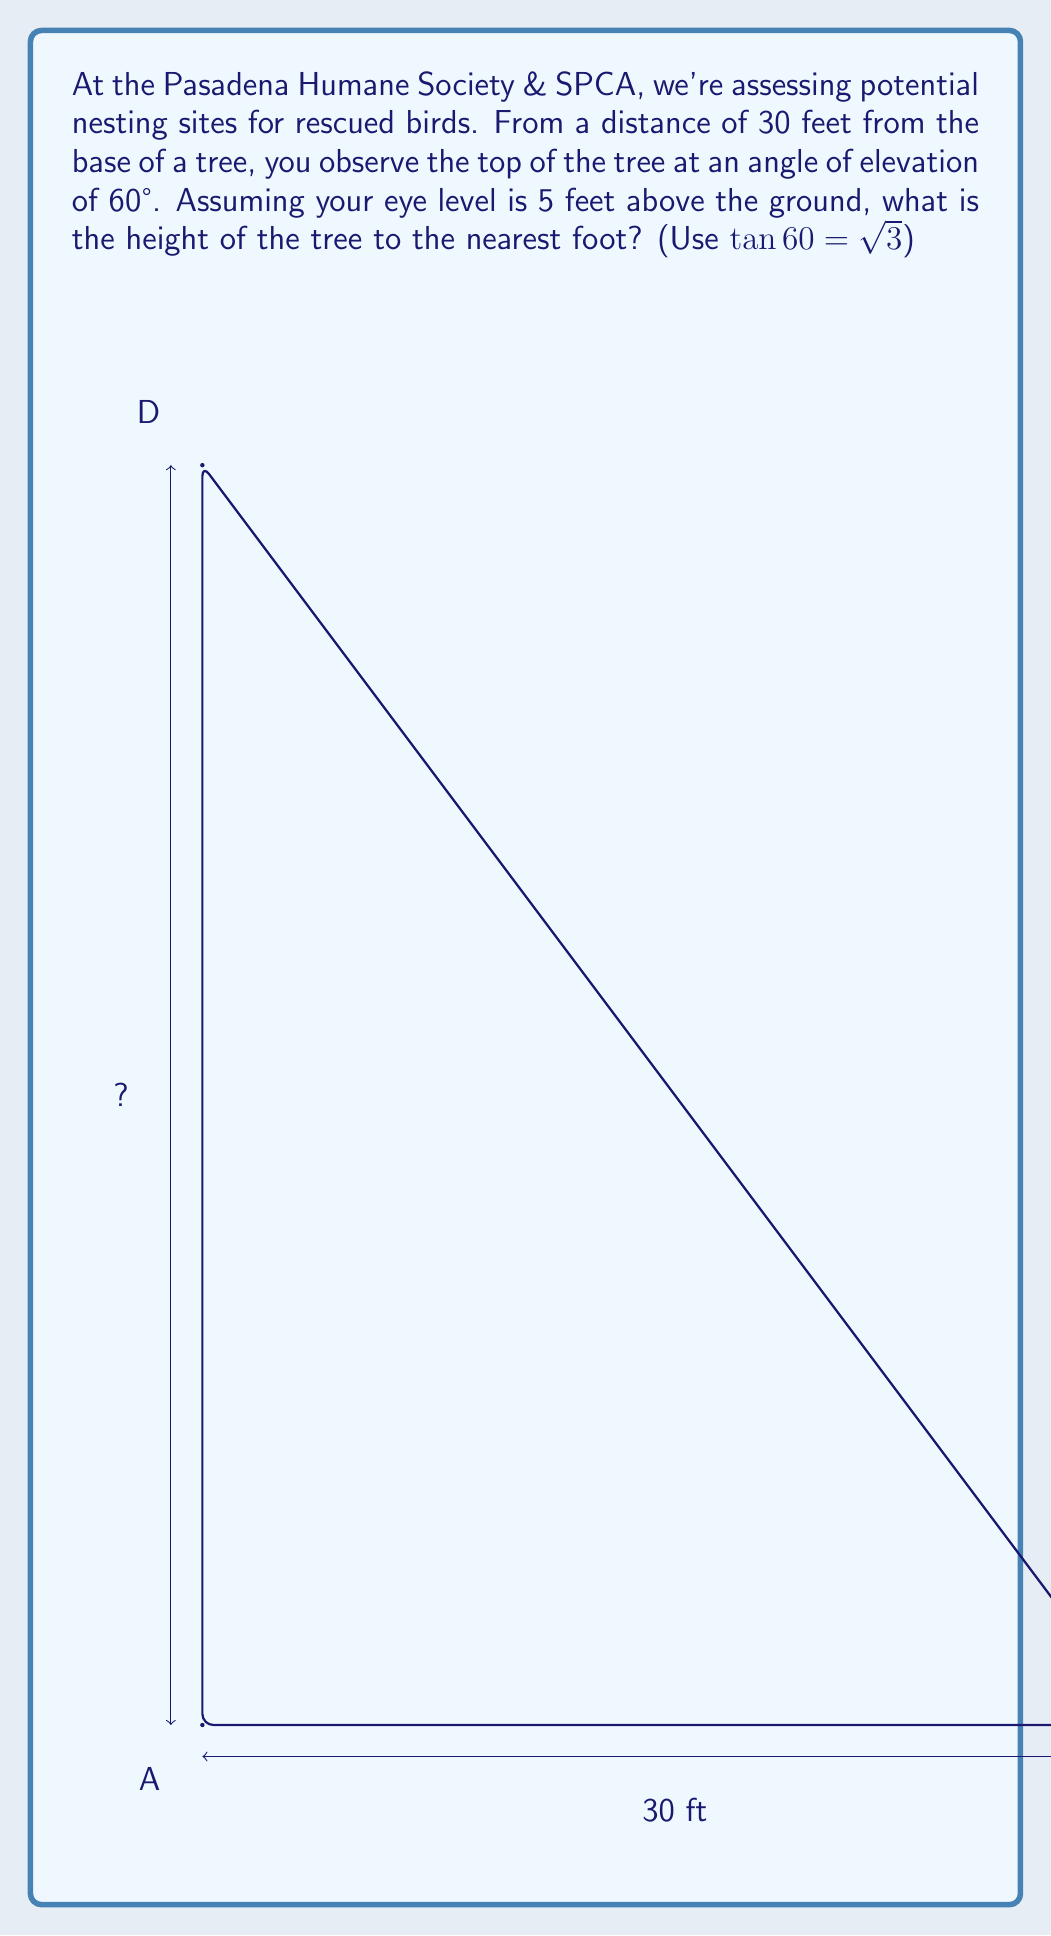Can you answer this question? Let's approach this step-by-step:

1) First, let's identify what we know:
   - Distance from the observer to the tree: 30 feet
   - Angle of elevation: 60°
   - Observer's eye level: 5 feet above ground
   - $\tan 60° = \sqrt{3}$

2) We can use the tangent ratio to find the height above the observer's eye level:

   $\tan 60° = \frac{\text{opposite}}{\text{adjacent}} = \frac{\text{height above eye level}}{30}$

3) Substituting the known value of $\tan 60°$:

   $\sqrt{3} = \frac{\text{height above eye level}}{30}$

4) Solve for the height above eye level:

   $\text{height above eye level} = 30\sqrt{3}$ feet

5) Calculate this value:
   
   $30\sqrt{3} \approx 51.96$ feet

6) To get the total height of the tree, add the observer's eye level:

   Total height $= 51.96 + 5 = 56.96$ feet

7) Rounding to the nearest foot:

   Total height $\approx 57$ feet
Answer: The height of the tree is approximately 57 feet. 